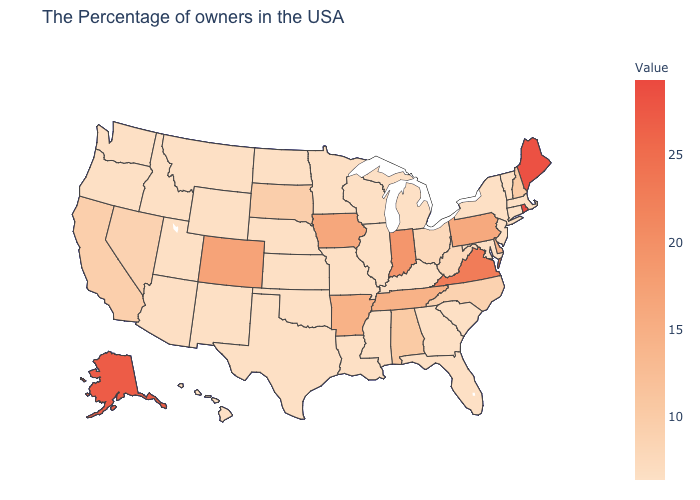Which states hav the highest value in the Northeast?
Concise answer only. Rhode Island. Which states have the lowest value in the USA?
Keep it brief. Massachusetts, Vermont, Connecticut, New York, New Jersey, Maryland, South Carolina, Florida, Georgia, Michigan, Kentucky, Wisconsin, Illinois, Mississippi, Louisiana, Missouri, Minnesota, Kansas, Nebraska, Oklahoma, Texas, North Dakota, Wyoming, New Mexico, Utah, Montana, Idaho, Washington, Oregon, Hawaii. Does Michigan have the highest value in the MidWest?
Write a very short answer. No. Which states have the highest value in the USA?
Answer briefly. Rhode Island. 